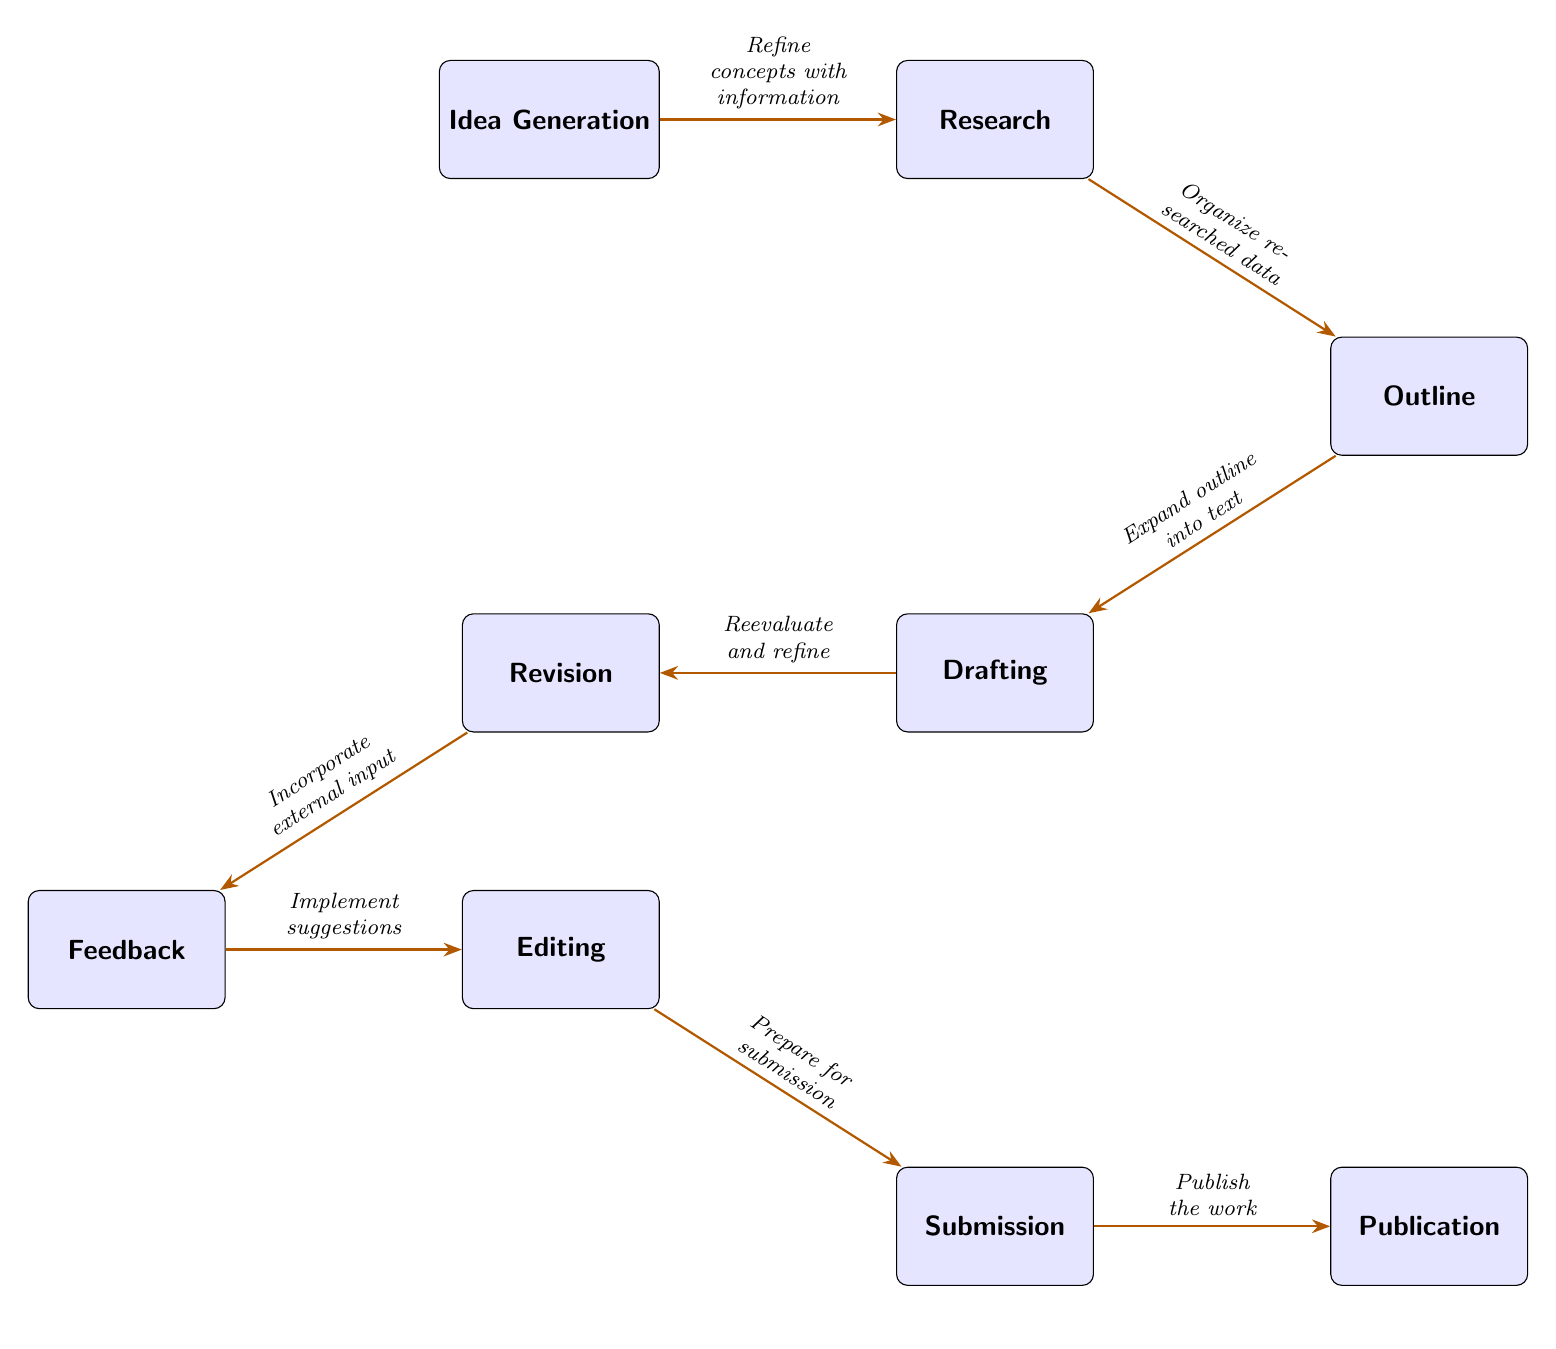What is the first step in the creative process? The diagram starts with "Idea Generation" as the first box, indicating that this is the initial step in the creative process.
Answer: Idea Generation How many nodes are present in the diagram? The diagram consists of eight nodes representing different stages in the creative process: Idea Generation, Research, Outline, Drafting, Revision, Feedback, Editing, Submission, and Publication. Counting these gives a total of eight nodes.
Answer: Eight What node comes immediately after Revision? Following the node "Revision" in the flow, the next node is "Feedback," which indicates that feedback is sought after the initial revision of the work.
Answer: Feedback What does the arrow between Editing and Submission signify? The arrow indicates a directional flow from the "Editing" box to the "Submission" box, clarifying that the editing process leads to submission, as indicated by the label "Prepare for submission."
Answer: Prepare for submission Which node involves external input? The "Feedback" node specifically represents the stage where external input is incorporated into the work, as described in the connecting label "Incorporate external input."
Answer: Feedback Which two nodes are connected by the arrow labeled "Expand outline into text"? This specific arrow connects the nodes "Outline" and "Drafting," illustrating the progression where an outline is expanded into a textual draft.
Answer: Outline and Drafting What is the last step before publication? The final process before reaching "Publication" is the "Submission" stage, where the work is prepared and formally submitted for publishing.
Answer: Submission What action is indicated between Research and Outline? The label on the arrow between "Research" and "Outline" states "Organize researched data," meaning this action reflects organizing the information gathered during the research phase to create an outline.
Answer: Organize researched data 